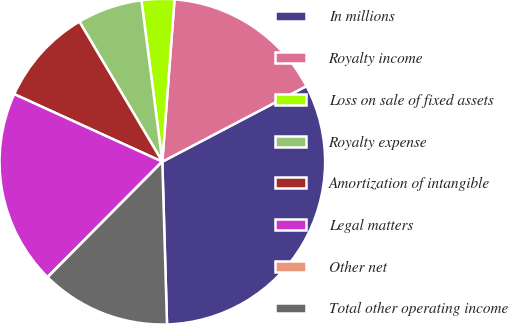Convert chart. <chart><loc_0><loc_0><loc_500><loc_500><pie_chart><fcel>In millions<fcel>Royalty income<fcel>Loss on sale of fixed assets<fcel>Royalty expense<fcel>Amortization of intangible<fcel>Legal matters<fcel>Other net<fcel>Total other operating income<nl><fcel>32.23%<fcel>16.12%<fcel>3.24%<fcel>6.46%<fcel>9.68%<fcel>19.35%<fcel>0.02%<fcel>12.9%<nl></chart> 